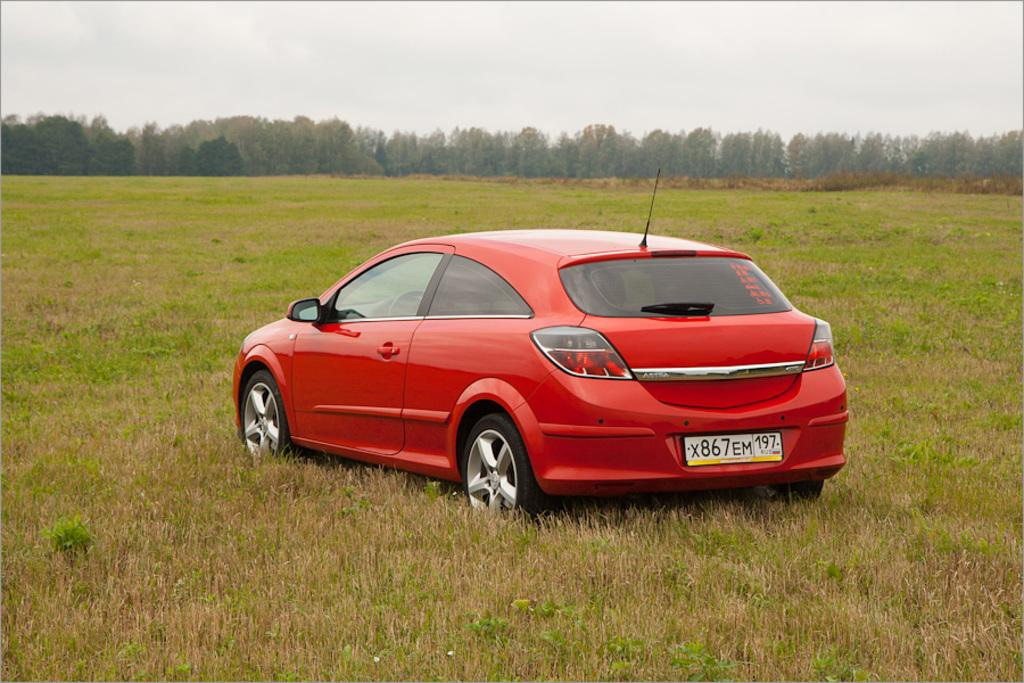What type of vegetation can be seen in the image? There are trees in the image. What else can be seen on the ground in the image? There is grass in the image. What is the main object located in the middle of the image? There is a car in the middle of the image. What is visible at the top of the image? The sky is visible at the top of the image. How many bubbles are floating around the car in the image? There are no bubbles present in the image; it features trees, grass, a car, and the sky. What type of stone is used to create the statement on the car's bumper? There is no statement or stone present on the car's bumper in the image. 